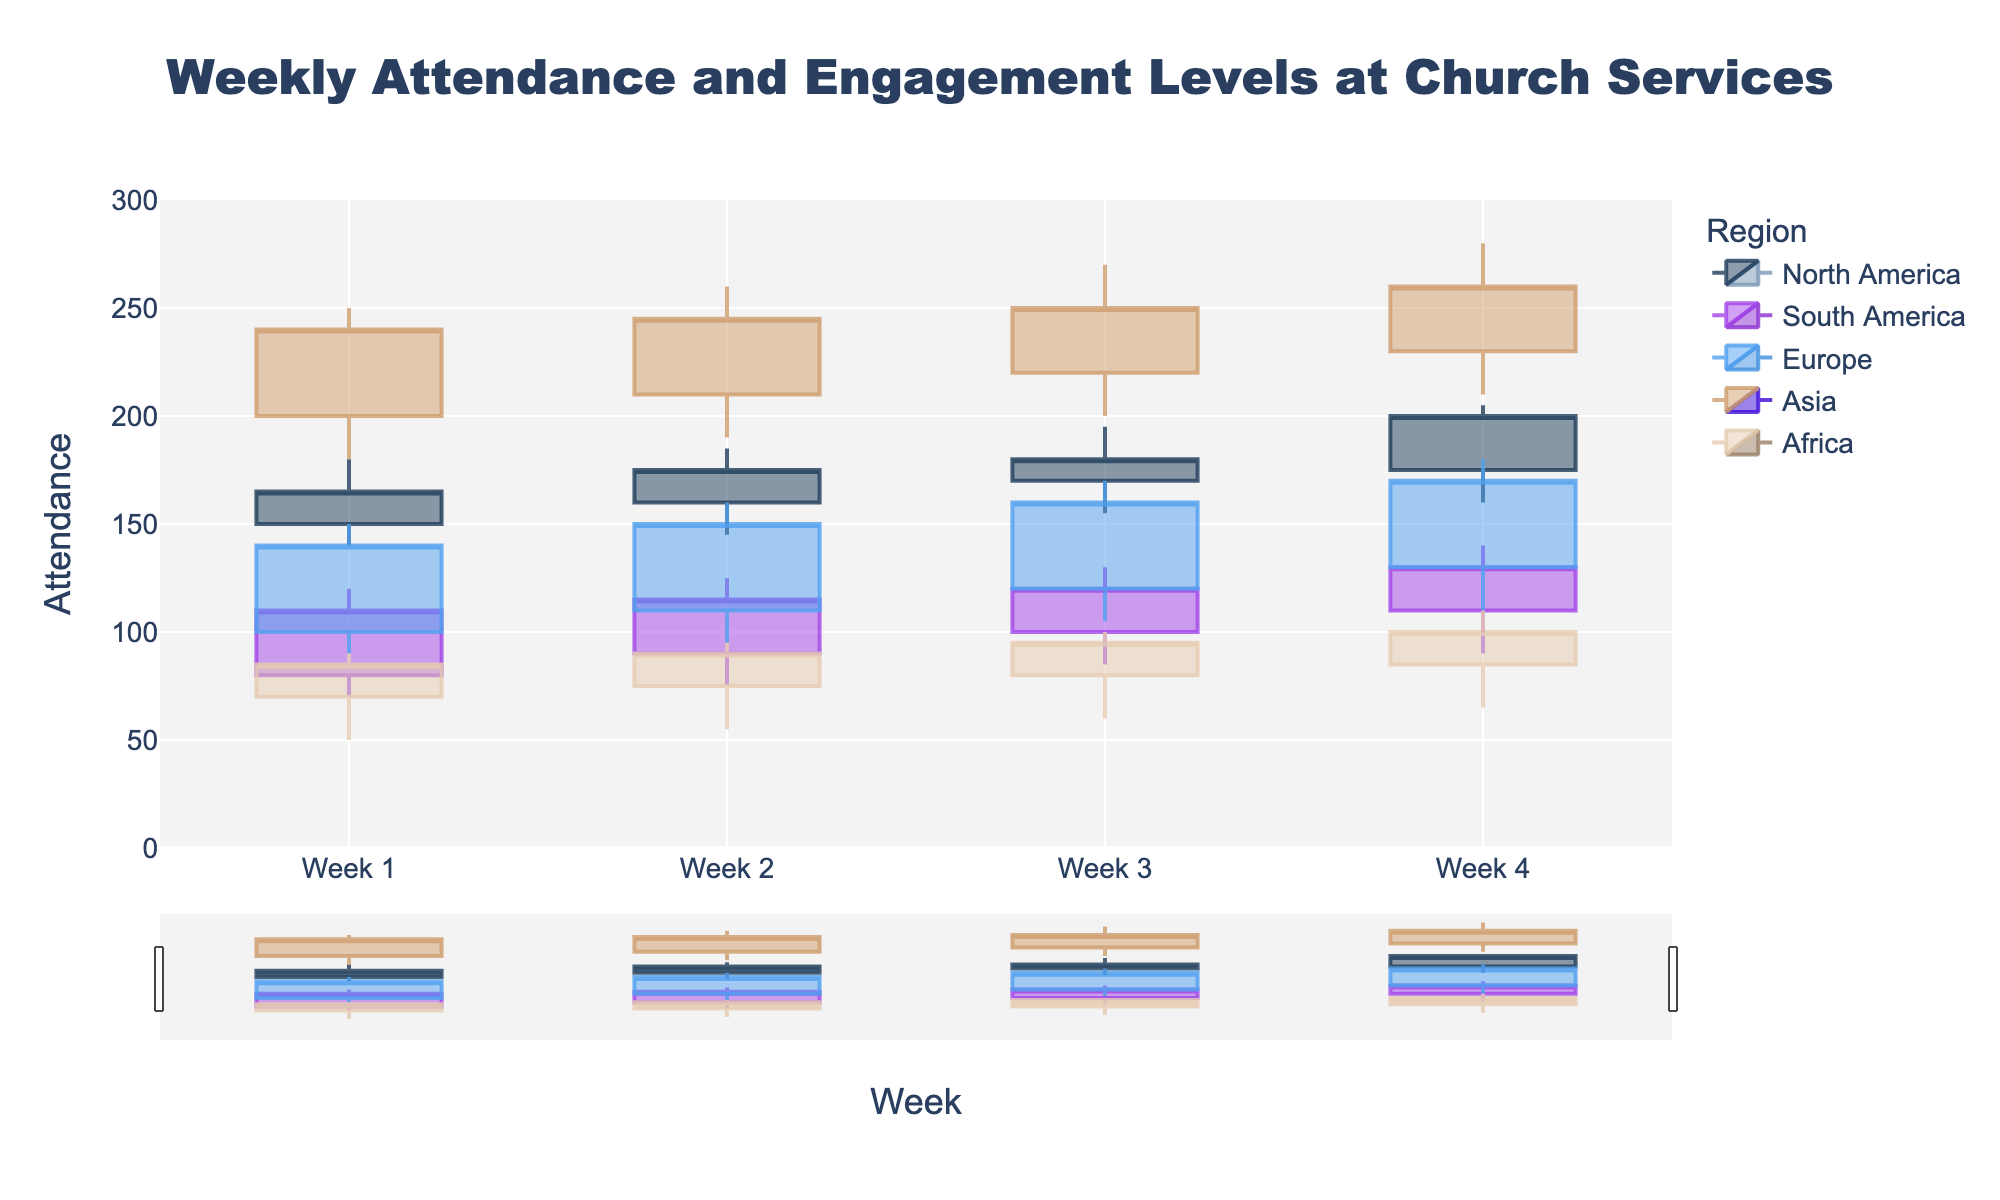What is the title of the chart? The title is written at the top of the figure. It reads "Weekly Attendance and Engagement Levels at Church Services".
Answer: Weekly Attendance and Engagement Levels at Church Services In which week does Asia have the highest attendance? Examine the candlestick for Asia in each week; the 'High' value in Week 4 is the highest.
Answer: Week 4 Comparing North America and Europe in Week 2, which region has the higher closing attendance? Look at the closing values for Week 2 for both regions. North America's close is 175, while Europe's is 150.
Answer: North America What is the range of attendance in South America during Week 4? The range is the difference between the highest and lowest values. For South America in Week 4, it is 140 - 90.
Answer: 50 How many distinct regions are displayed in the chart? Each region's data is a separate candlestick group on the chart. Counting these groups gives five regions: North America, South America, Europe, Asia, and Africa.
Answer: 5 Which region experienced a decrease in attendance from Week 3 to Week 4? Check the closing values from Week 3 to Week 4 in each region. North America's and Africa's closing values increased, but South America, Europe, and Asia's closing values increased. None decreased.
Answer: None What is the average opening attendance in North America over the four weeks? Sum the opening values for each week in North America and divide by 4: (150 + 160 + 170 + 175) / 4.
Answer: 163.75 Which region shows the most consistent (least variation) attendance in the first week? The consistency can be inferred from the difference between 'High' and 'Low' values (range). Africa has the smallest range (90 - 50 = 40).
Answer: Africa By how much did the attendance increase for Africa from Week 1 to Week 4? Compare the closing values of Week 1 and Week 4 for Africa: 100 - 85.
Answer: 15 In which week did Europe have the highest increase in attendance compared to the previous week? Look at the difference in closing values between consecutive weeks for Europe. The increase from Week 3 to Week 4 is 170 - 160 = 10.
Answer: Week 4 